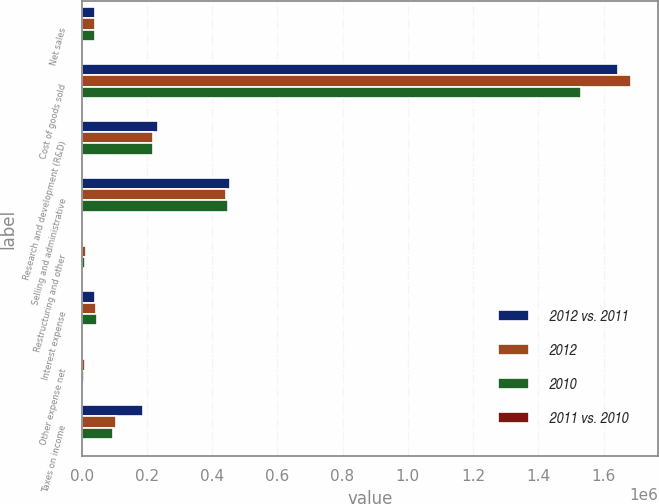Convert chart to OTSL. <chart><loc_0><loc_0><loc_500><loc_500><stacked_bar_chart><ecel><fcel>Net sales<fcel>Cost of goods sold<fcel>Research and development (R&D)<fcel>Selling and administrative<fcel>Restructuring and other<fcel>Interest expense<fcel>Other expense net<fcel>Taxes on income<nl><fcel>2012 vs. 2011<fcel>41753<fcel>1.64591e+06<fcel>233713<fcel>453535<fcel>1668<fcel>41753<fcel>1450<fcel>189281<nl><fcel>2012<fcel>41753<fcel>1.68336e+06<fcel>219781<fcel>443974<fcel>13172<fcel>44639<fcel>9544<fcel>106680<nl><fcel>2010<fcel>41753<fcel>1.53026e+06<fcel>218772<fcel>447392<fcel>10077<fcel>48709<fcel>8059<fcel>96036<nl><fcel>2011 vs. 2010<fcel>1.2<fcel>2.2<fcel>6.3<fcel>2.2<fcel>87.3<fcel>6.5<fcel>84.8<fcel>77.4<nl></chart> 